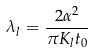Convert formula to latex. <formula><loc_0><loc_0><loc_500><loc_500>\lambda _ { l } = \frac { 2 \alpha ^ { 2 } } { \pi K _ { l } t _ { 0 } }</formula> 